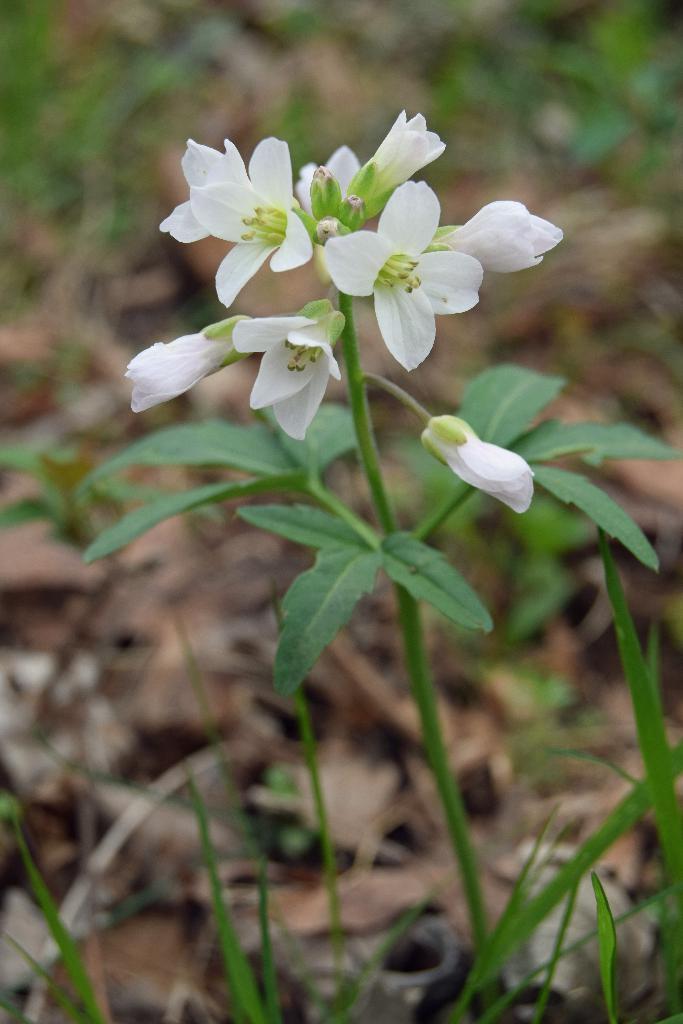How would you summarize this image in a sentence or two? In the image there are white color flowers, buds and leaves to the stem. And also there are leaves at the bottom of the image. In the background it is a blur image and there are leaves. 